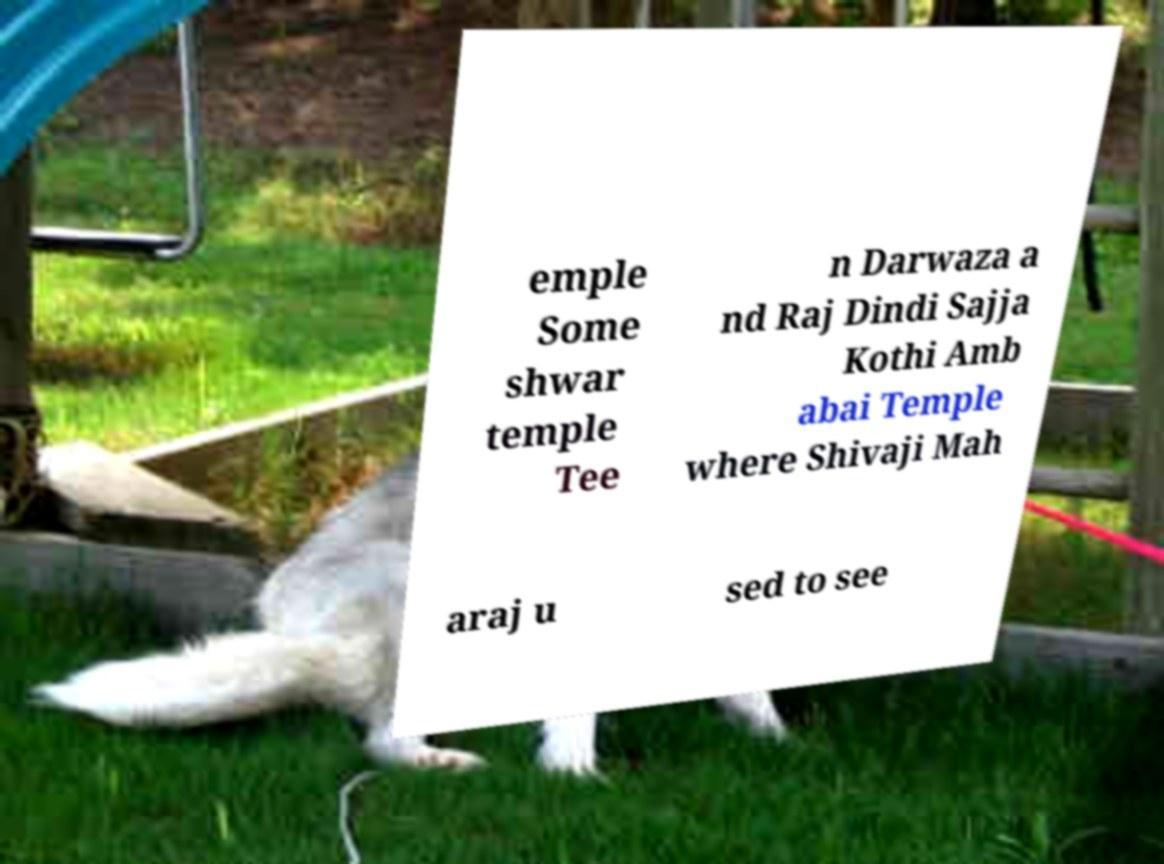Please identify and transcribe the text found in this image. emple Some shwar temple Tee n Darwaza a nd Raj Dindi Sajja Kothi Amb abai Temple where Shivaji Mah araj u sed to see 